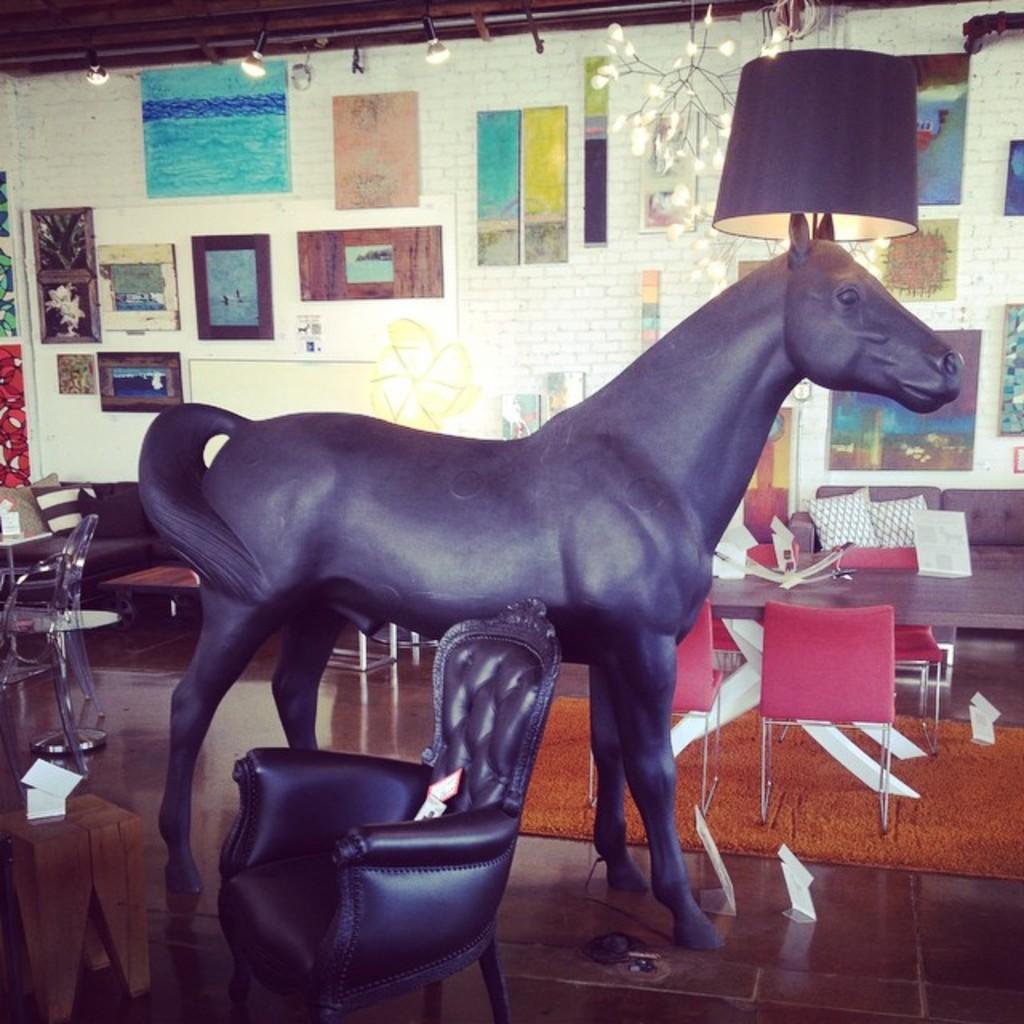Describe this image in one or two sentences. The picture is taken in a room. In the foreground of the picture there is a couch and a statue of horse. In the center of the picture there are tables, chairs, couches and pillows. In the background on the wall there are frames. At the top there are lights and lamp. 